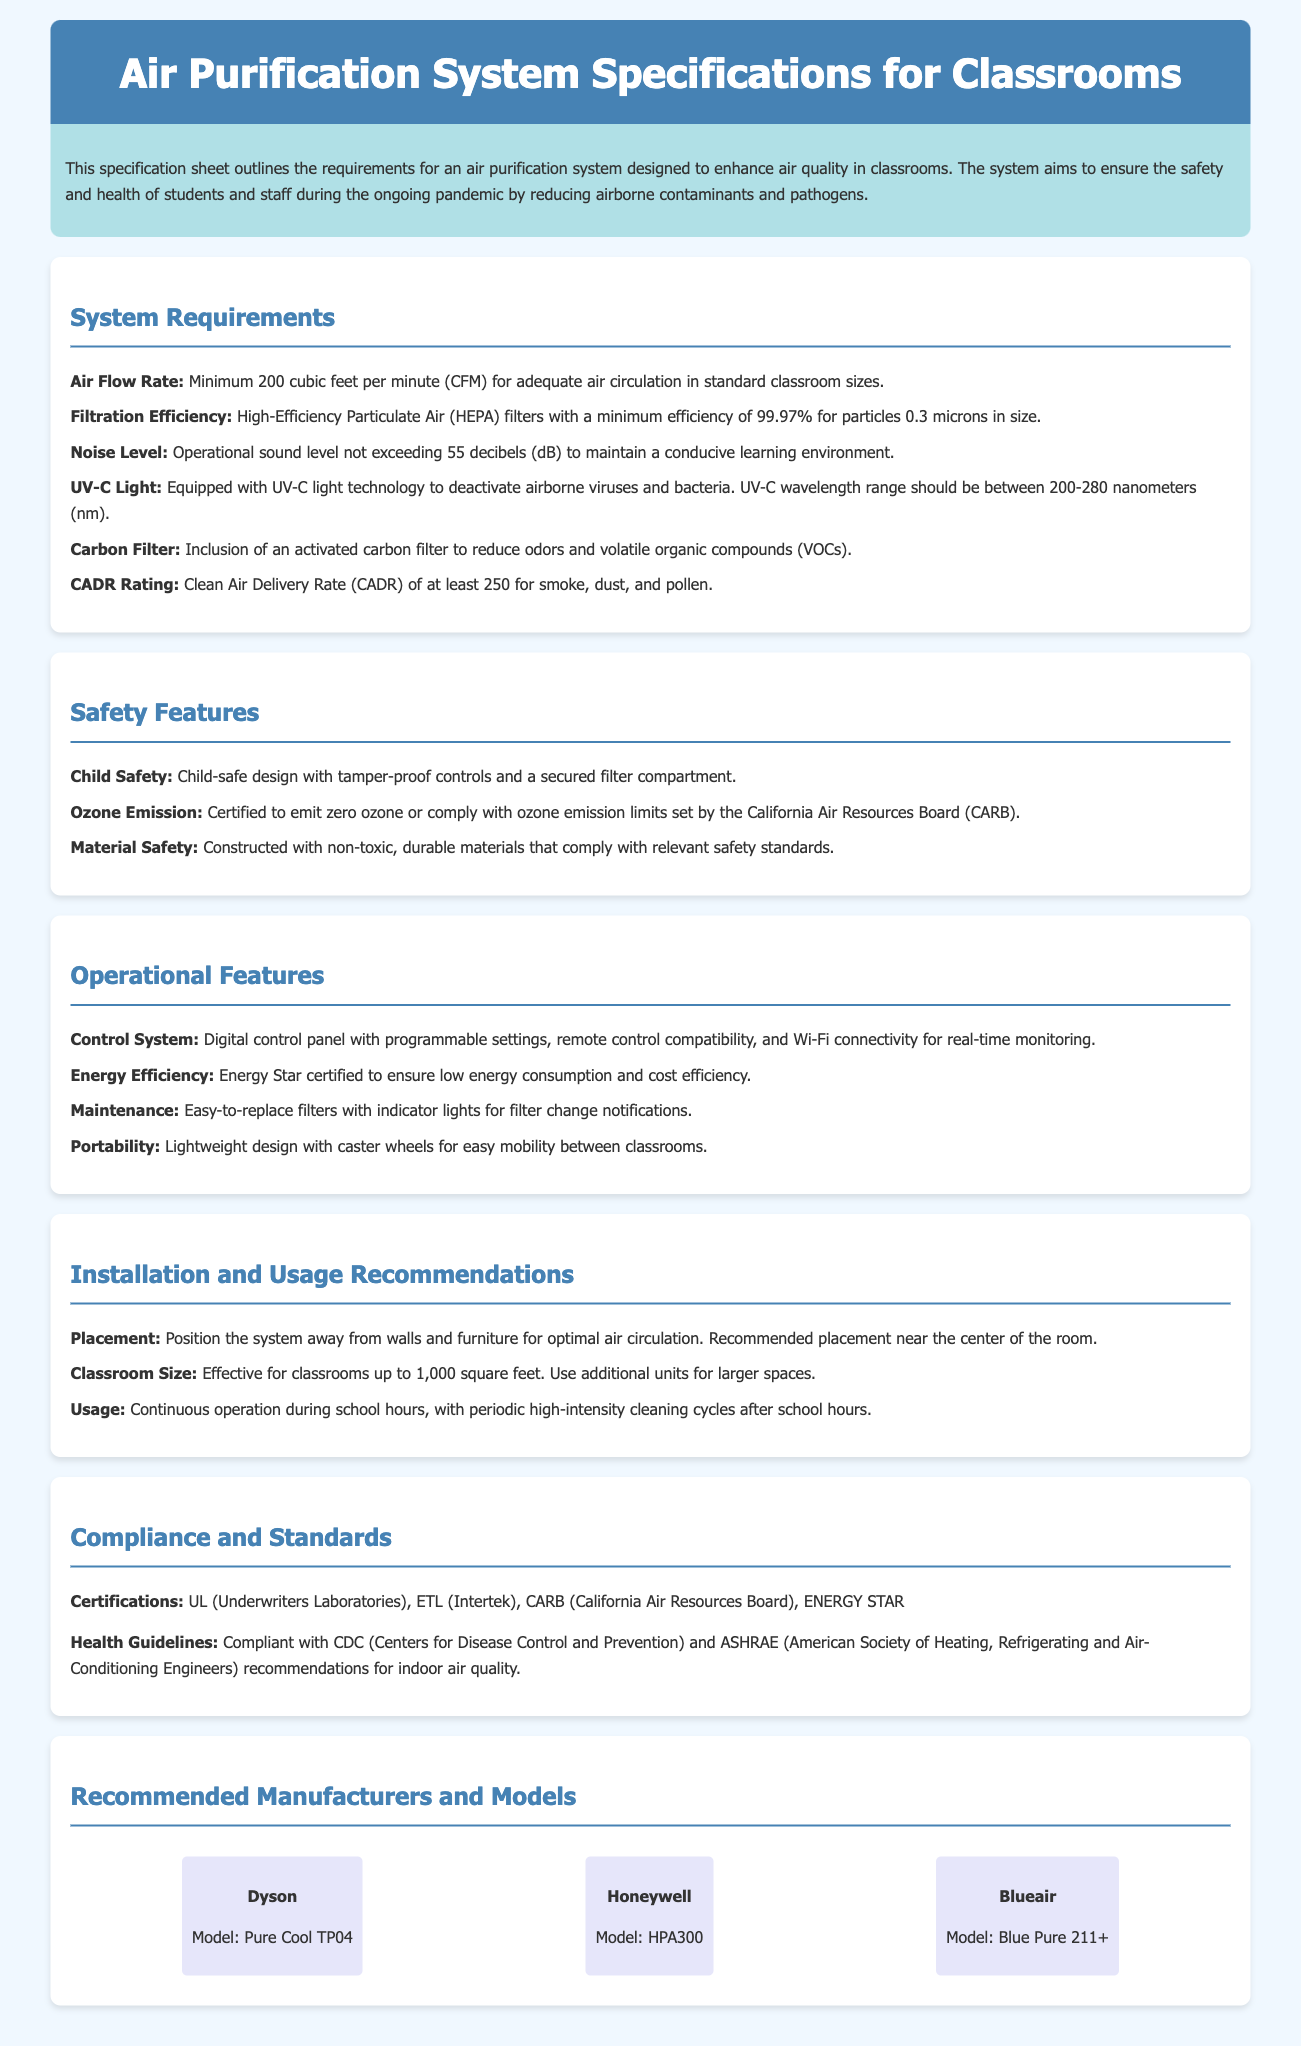What is the minimum air flow rate required? The minimum air flow rate for adequate air circulation in standard classroom sizes is specified in the document.
Answer: 200 cubic feet per minute (CFM) What type of filters does the system use? The document specifies the filtration efficiency type that the air purification system must incorporate.
Answer: High-Efficiency Particulate Air (HEPA) What is the maximum operational noise level? The maximum sound level that should be maintained as stated in the document is important for a conducive learning environment.
Answer: 55 decibels (dB) What is included to reduce odors and VOCs? The inclusion of a specific filter type aimed at reducing unpleasant smells and harmful compounds is listed in the document.
Answer: Activated carbon filter What is the Clean Air Delivery Rate (CADR) requirement? The required CADR rating for smoke, dust, and pollen ensures high air quality standards as mentioned in the specifications.
Answer: At least 250 What safety feature ensures child safety? The document highlights a specific design feature that protects children regarding the operation of the system.
Answer: Tamper-proof controls How are the filters designed for maintenance? The document outlines how the system supports ease of maintenance through specific indicators.
Answer: Easy-to-replace filters with indicator lights What is the recommended system placement? Proper placement guidelines for optimal air circulation in classrooms are specified in the document.
Answer: Near the center of the room Which organizations' guidelines does the system comply with? The document includes the names of key health organizations whose recommendations must be followed for safety standards.
Answer: CDC and ASHRAE 